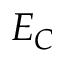<formula> <loc_0><loc_0><loc_500><loc_500>E _ { C }</formula> 